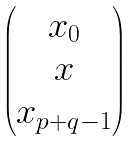Convert formula to latex. <formula><loc_0><loc_0><loc_500><loc_500>\begin{pmatrix} x _ { 0 } \\ x \\ x _ { p + q - 1 } \end{pmatrix}</formula> 